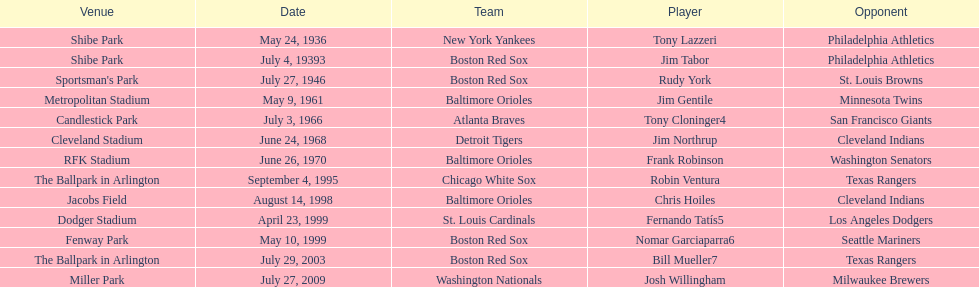When did the detroit tigers and the cleveland indians have a match? June 24, 1968. 